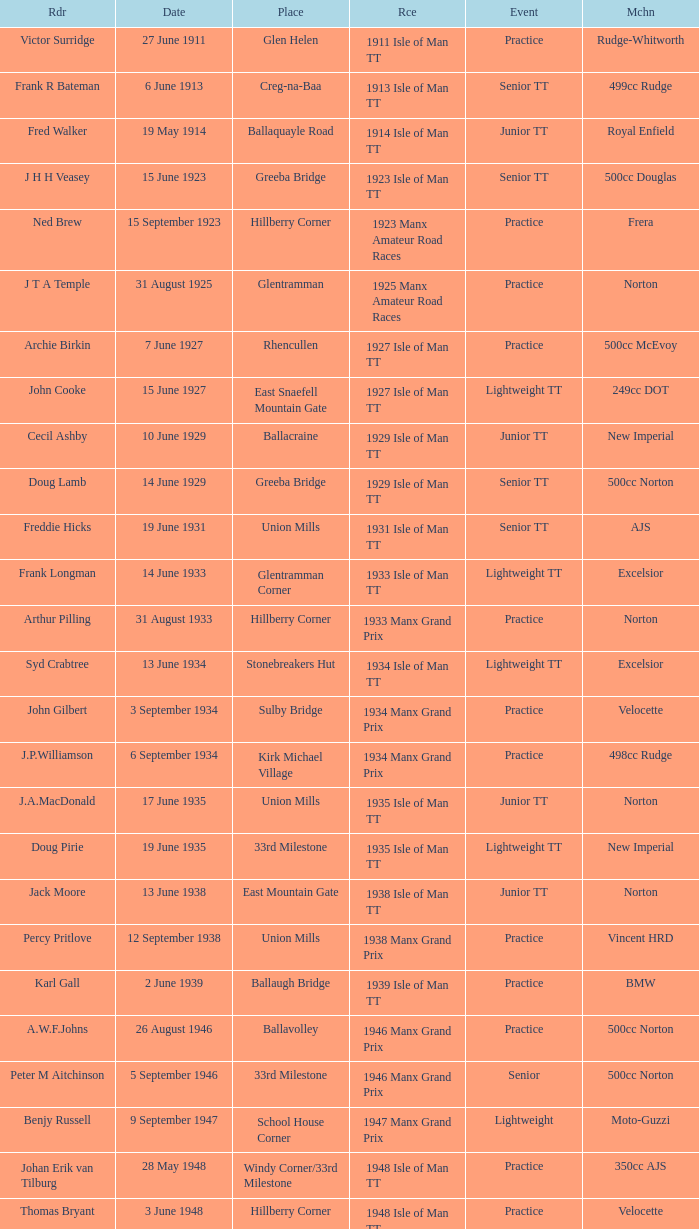What event was Rob Vine riding? Senior TT. 